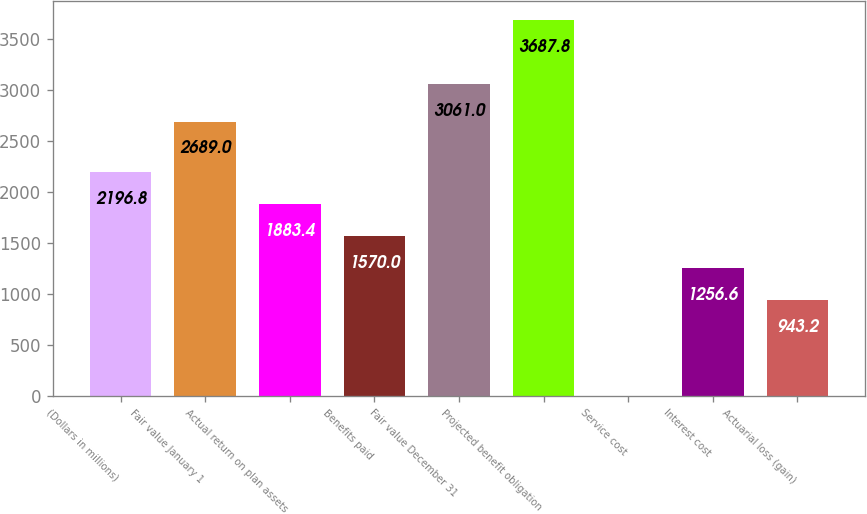<chart> <loc_0><loc_0><loc_500><loc_500><bar_chart><fcel>(Dollars in millions)<fcel>Fair value January 1<fcel>Actual return on plan assets<fcel>Benefits paid<fcel>Fair value December 31<fcel>Projected benefit obligation<fcel>Service cost<fcel>Interest cost<fcel>Actuarial loss (gain)<nl><fcel>2196.8<fcel>2689<fcel>1883.4<fcel>1570<fcel>3061<fcel>3687.8<fcel>3<fcel>1256.6<fcel>943.2<nl></chart> 